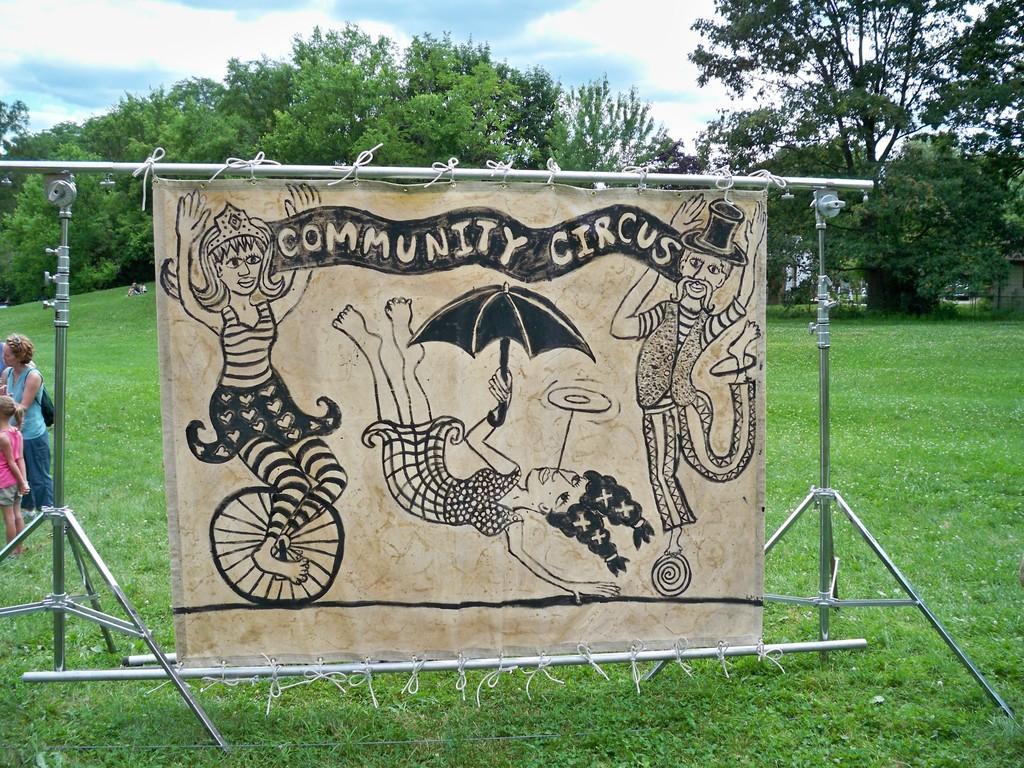How would you summarize this image in a sentence or two? In the image there is a poster with few images and something written on it. And it is hanged on the rods and stands. On the right side of the image there are few people standing. On the ground there is grass. In the background there are trees. At the top of the image there is a sky with clouds. 